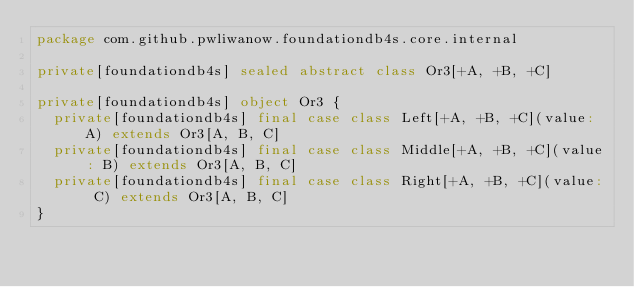<code> <loc_0><loc_0><loc_500><loc_500><_Scala_>package com.github.pwliwanow.foundationdb4s.core.internal

private[foundationdb4s] sealed abstract class Or3[+A, +B, +C]

private[foundationdb4s] object Or3 {
  private[foundationdb4s] final case class Left[+A, +B, +C](value: A) extends Or3[A, B, C]
  private[foundationdb4s] final case class Middle[+A, +B, +C](value: B) extends Or3[A, B, C]
  private[foundationdb4s] final case class Right[+A, +B, +C](value: C) extends Or3[A, B, C]
}
</code> 